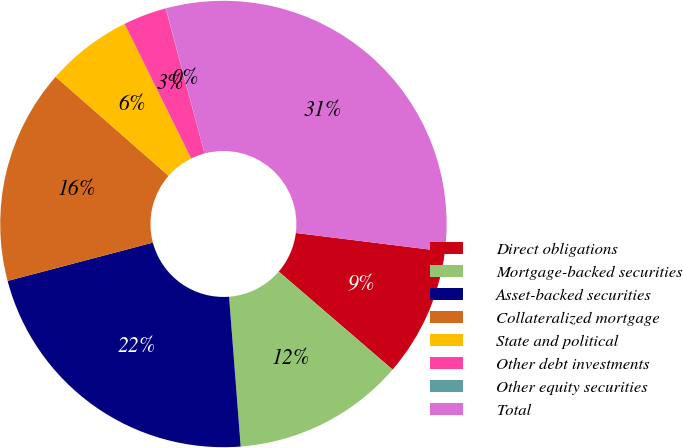Convert chart. <chart><loc_0><loc_0><loc_500><loc_500><pie_chart><fcel>Direct obligations<fcel>Mortgage-backed securities<fcel>Asset-backed securities<fcel>Collateralized mortgage<fcel>State and political<fcel>Other debt investments<fcel>Other equity securities<fcel>Total<nl><fcel>9.35%<fcel>12.46%<fcel>22.13%<fcel>15.57%<fcel>6.24%<fcel>3.13%<fcel>0.02%<fcel>31.12%<nl></chart> 